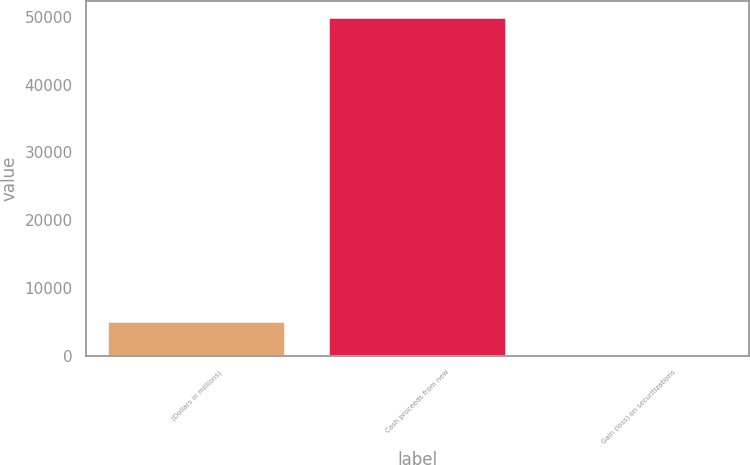<chart> <loc_0><loc_0><loc_500><loc_500><bar_chart><fcel>(Dollars in millions)<fcel>Cash proceeds from new<fcel>Gain (loss) on securitizations<nl><fcel>5061.7<fcel>49888<fcel>81<nl></chart> 